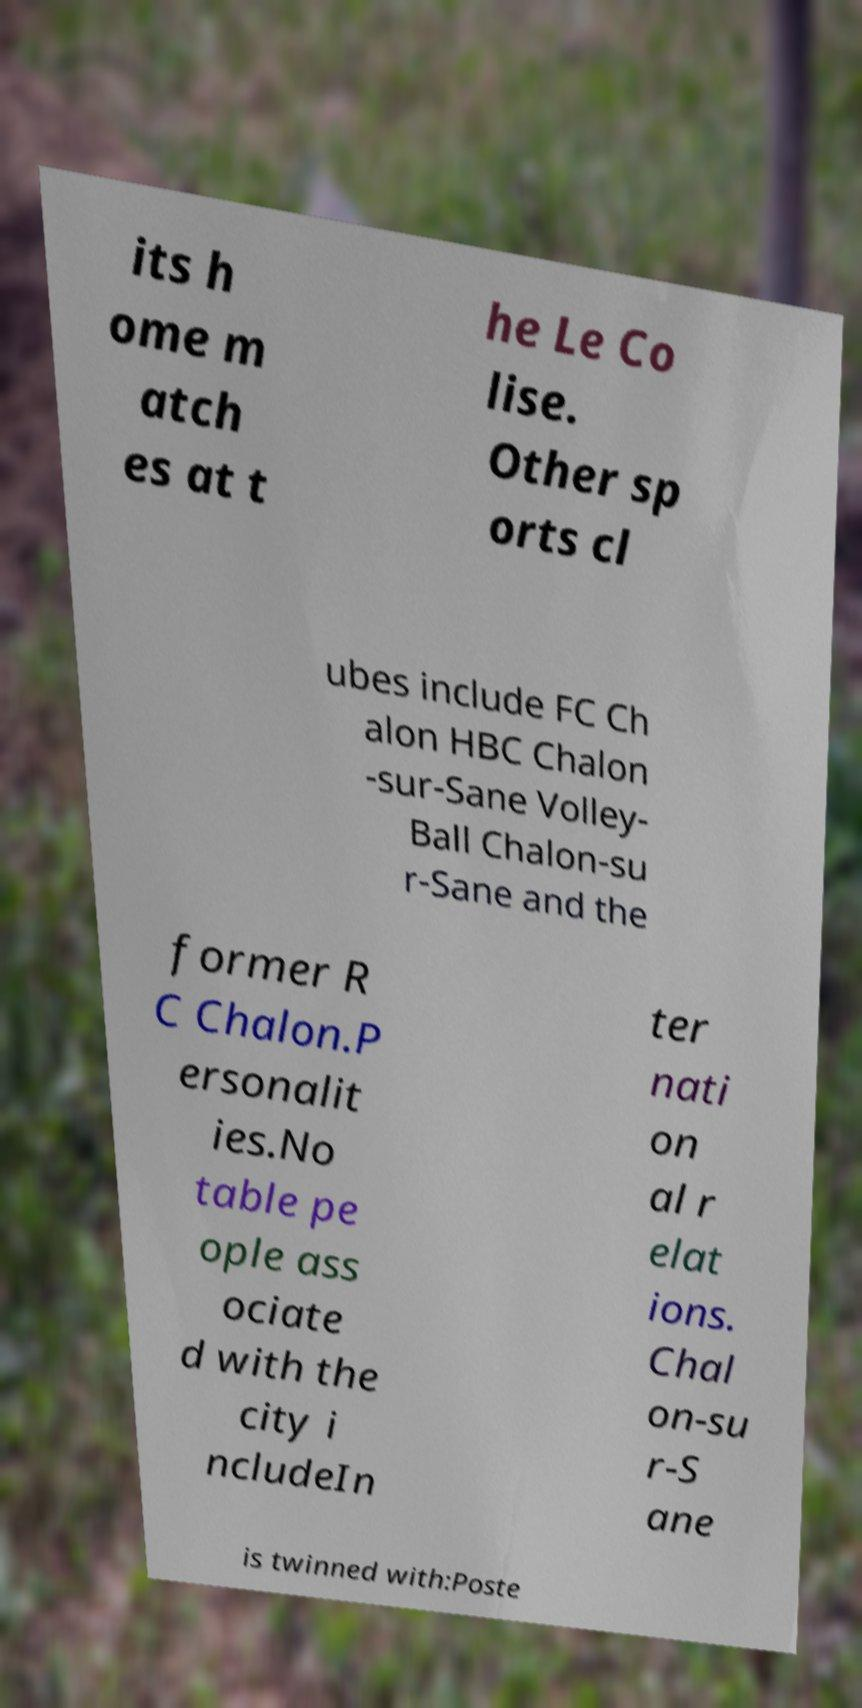Could you assist in decoding the text presented in this image and type it out clearly? its h ome m atch es at t he Le Co lise. Other sp orts cl ubes include FC Ch alon HBC Chalon -sur-Sane Volley- Ball Chalon-su r-Sane and the former R C Chalon.P ersonalit ies.No table pe ople ass ociate d with the city i ncludeIn ter nati on al r elat ions. Chal on-su r-S ane is twinned with:Poste 